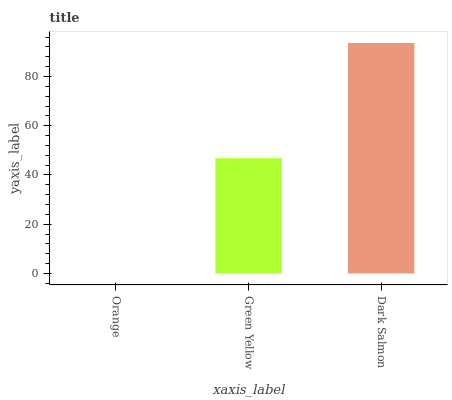Is Dark Salmon the maximum?
Answer yes or no. Yes. Is Green Yellow the minimum?
Answer yes or no. No. Is Green Yellow the maximum?
Answer yes or no. No. Is Green Yellow greater than Orange?
Answer yes or no. Yes. Is Orange less than Green Yellow?
Answer yes or no. Yes. Is Orange greater than Green Yellow?
Answer yes or no. No. Is Green Yellow less than Orange?
Answer yes or no. No. Is Green Yellow the high median?
Answer yes or no. Yes. Is Green Yellow the low median?
Answer yes or no. Yes. Is Dark Salmon the high median?
Answer yes or no. No. Is Dark Salmon the low median?
Answer yes or no. No. 